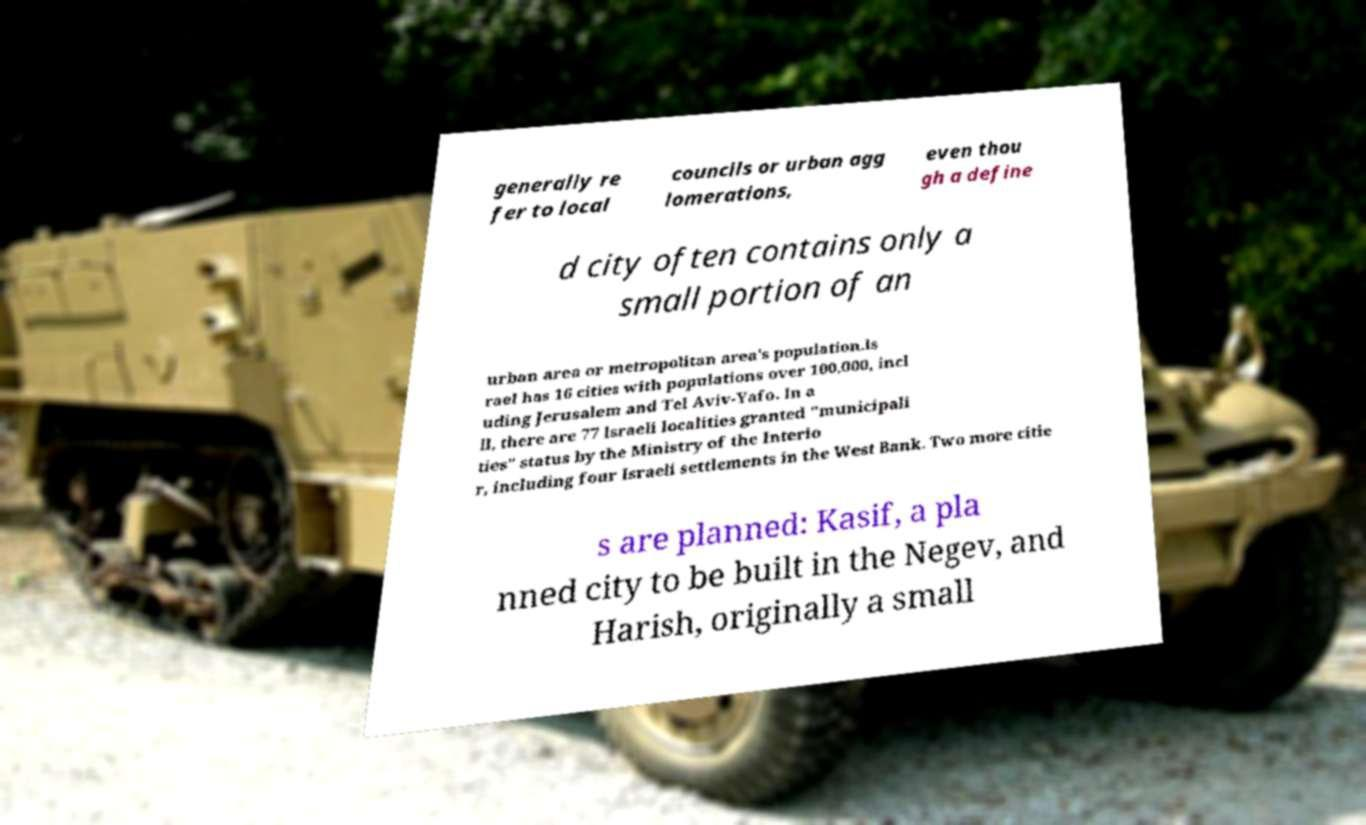Could you assist in decoding the text presented in this image and type it out clearly? generally re fer to local councils or urban agg lomerations, even thou gh a define d city often contains only a small portion of an urban area or metropolitan area's population.Is rael has 16 cities with populations over 100,000, incl uding Jerusalem and Tel Aviv-Yafo. In a ll, there are 77 Israeli localities granted "municipali ties" status by the Ministry of the Interio r, including four Israeli settlements in the West Bank. Two more citie s are planned: Kasif, a pla nned city to be built in the Negev, and Harish, originally a small 